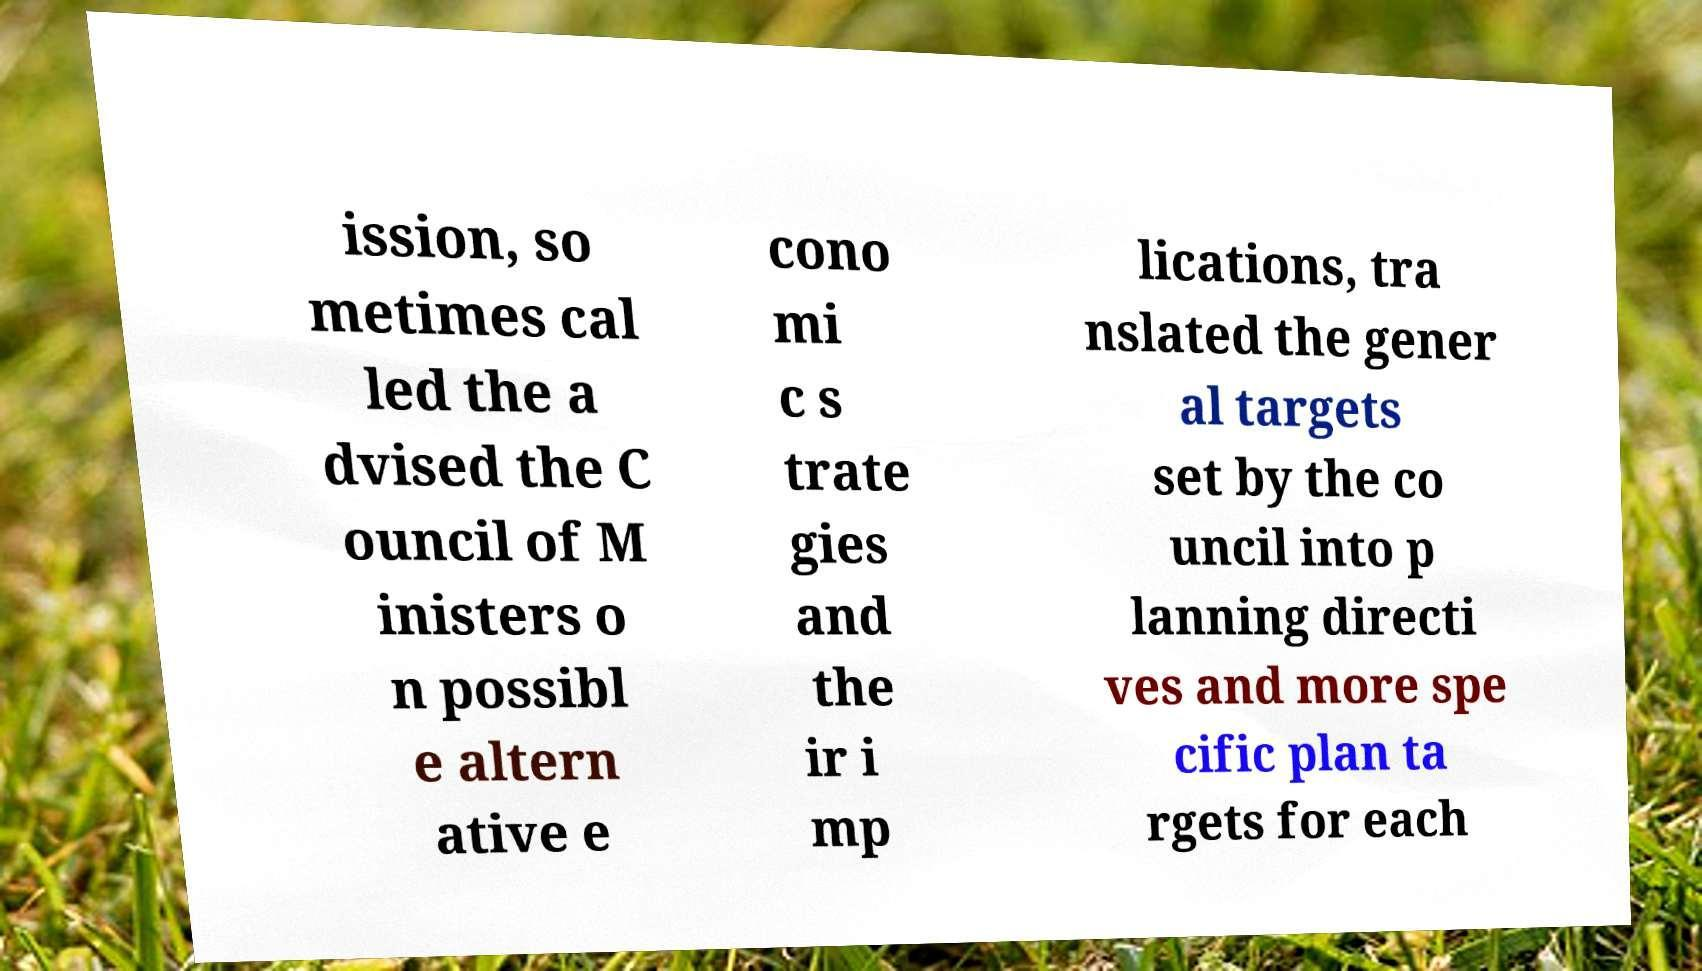Could you extract and type out the text from this image? ission, so metimes cal led the a dvised the C ouncil of M inisters o n possibl e altern ative e cono mi c s trate gies and the ir i mp lications, tra nslated the gener al targets set by the co uncil into p lanning directi ves and more spe cific plan ta rgets for each 